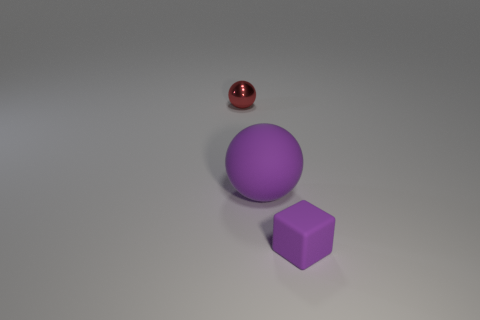Add 3 rubber spheres. How many objects exist? 6 Subtract all blocks. How many objects are left? 2 Add 1 red metal objects. How many red metal objects are left? 2 Add 1 tiny blue matte balls. How many tiny blue matte balls exist? 1 Subtract 1 purple balls. How many objects are left? 2 Subtract all big rubber cylinders. Subtract all large rubber balls. How many objects are left? 2 